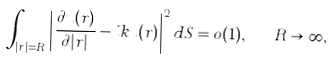<formula> <loc_0><loc_0><loc_500><loc_500>\int _ { | r | = R } \left | \frac { \partial u ( r ) } { \partial | r | } - i k u ( r ) \right | ^ { 2 } d S = o ( 1 ) , \quad R \rightarrow \infty ,</formula> 